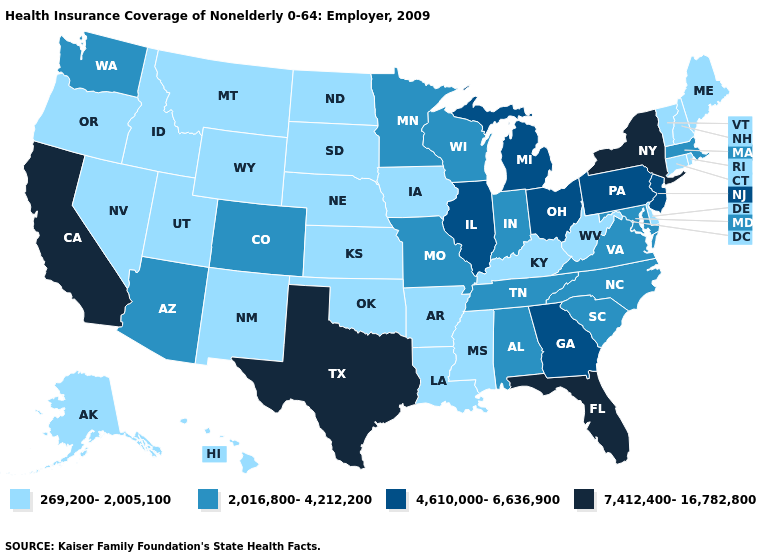Among the states that border Illinois , does Iowa have the lowest value?
Give a very brief answer. Yes. Does Vermont have the highest value in the Northeast?
Concise answer only. No. Name the states that have a value in the range 2,016,800-4,212,200?
Be succinct. Alabama, Arizona, Colorado, Indiana, Maryland, Massachusetts, Minnesota, Missouri, North Carolina, South Carolina, Tennessee, Virginia, Washington, Wisconsin. Name the states that have a value in the range 7,412,400-16,782,800?
Quick response, please. California, Florida, New York, Texas. Name the states that have a value in the range 4,610,000-6,636,900?
Short answer required. Georgia, Illinois, Michigan, New Jersey, Ohio, Pennsylvania. Among the states that border South Dakota , does North Dakota have the highest value?
Keep it brief. No. What is the highest value in states that border Nebraska?
Give a very brief answer. 2,016,800-4,212,200. Among the states that border Missouri , which have the lowest value?
Keep it brief. Arkansas, Iowa, Kansas, Kentucky, Nebraska, Oklahoma. Among the states that border New Hampshire , which have the lowest value?
Keep it brief. Maine, Vermont. Does New Hampshire have the lowest value in the USA?
Short answer required. Yes. Name the states that have a value in the range 4,610,000-6,636,900?
Concise answer only. Georgia, Illinois, Michigan, New Jersey, Ohio, Pennsylvania. Does California have the highest value in the USA?
Answer briefly. Yes. What is the value of Kentucky?
Answer briefly. 269,200-2,005,100. Does the map have missing data?
Be succinct. No. What is the highest value in states that border New Hampshire?
Concise answer only. 2,016,800-4,212,200. 